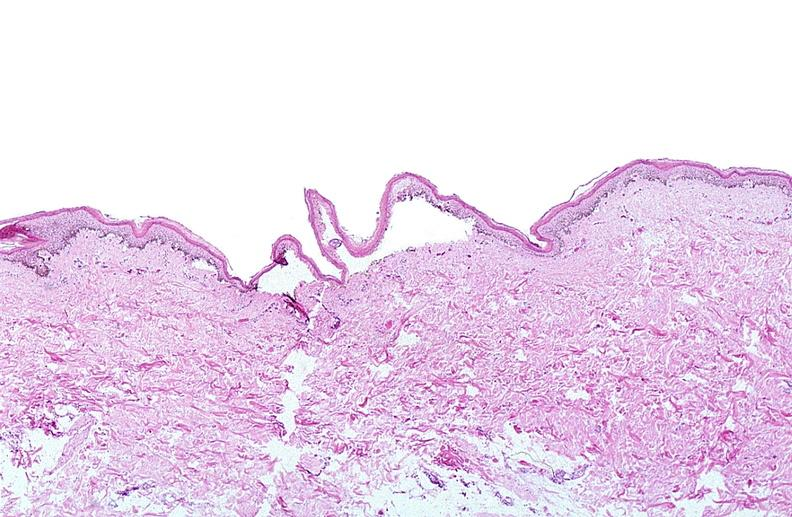what does this image show?
Answer the question using a single word or phrase. Thermal burned skin 